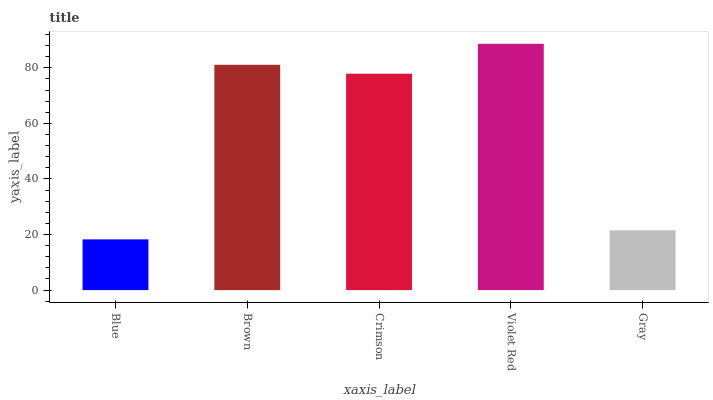Is Blue the minimum?
Answer yes or no. Yes. Is Violet Red the maximum?
Answer yes or no. Yes. Is Brown the minimum?
Answer yes or no. No. Is Brown the maximum?
Answer yes or no. No. Is Brown greater than Blue?
Answer yes or no. Yes. Is Blue less than Brown?
Answer yes or no. Yes. Is Blue greater than Brown?
Answer yes or no. No. Is Brown less than Blue?
Answer yes or no. No. Is Crimson the high median?
Answer yes or no. Yes. Is Crimson the low median?
Answer yes or no. Yes. Is Gray the high median?
Answer yes or no. No. Is Brown the low median?
Answer yes or no. No. 